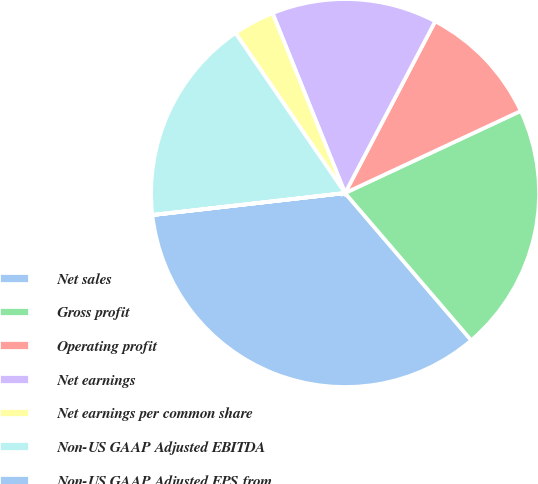Convert chart to OTSL. <chart><loc_0><loc_0><loc_500><loc_500><pie_chart><fcel>Net sales<fcel>Gross profit<fcel>Operating profit<fcel>Net earnings<fcel>Net earnings per common share<fcel>Non-US GAAP Adjusted EBITDA<fcel>Non-US GAAP Adjusted EPS from<nl><fcel>34.46%<fcel>20.68%<fcel>10.35%<fcel>13.79%<fcel>3.46%<fcel>17.24%<fcel>0.01%<nl></chart> 